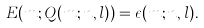<formula> <loc_0><loc_0><loc_500><loc_500>E ( m ; Q ( m ; n , l ) ) = \epsilon ( m ; n , l ) .</formula> 